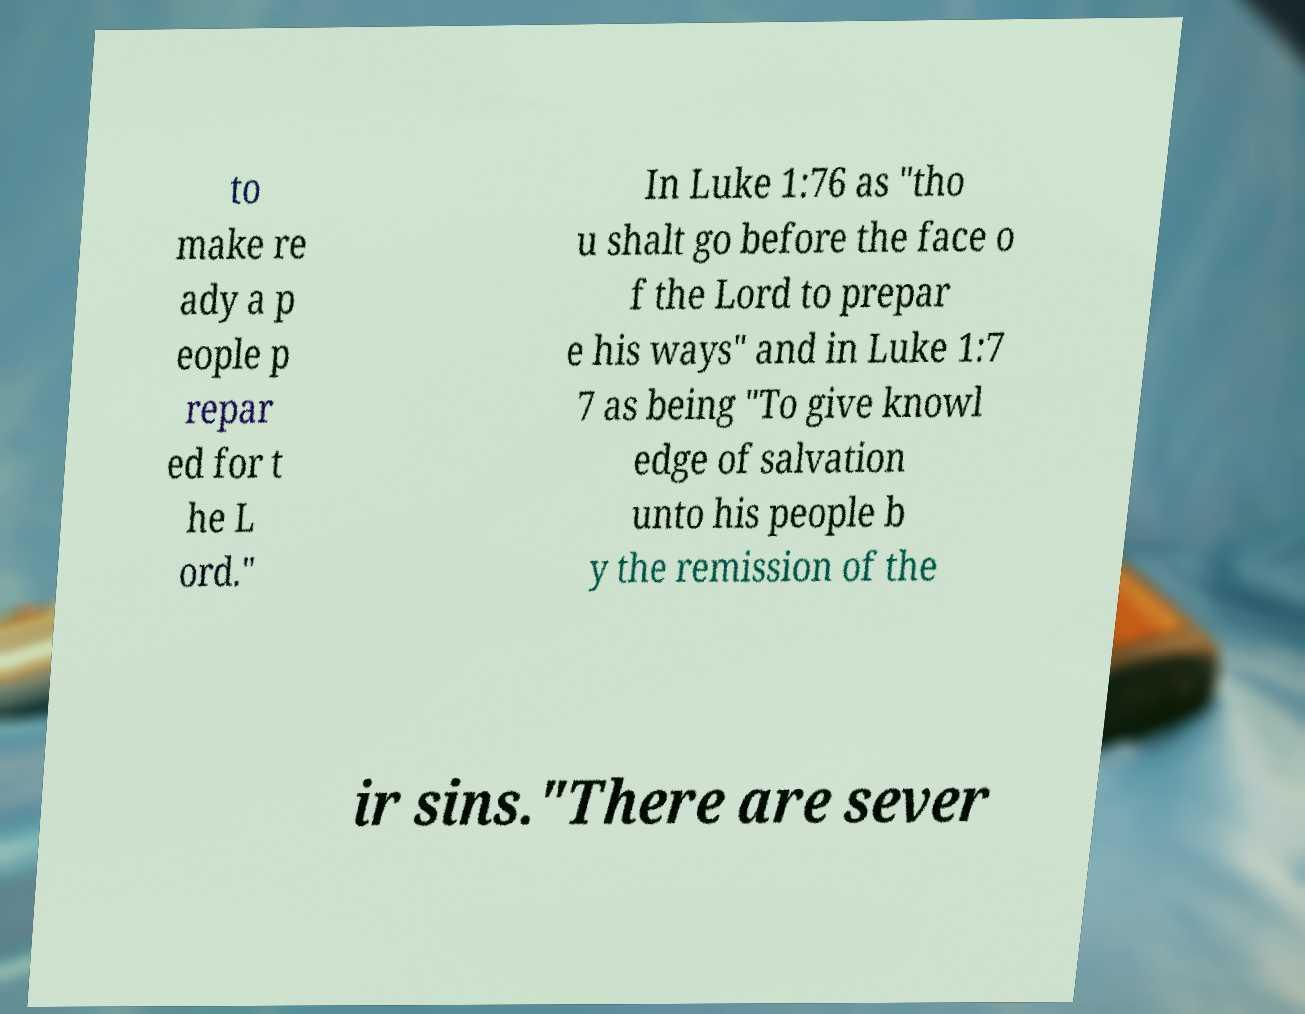Can you read and provide the text displayed in the image?This photo seems to have some interesting text. Can you extract and type it out for me? to make re ady a p eople p repar ed for t he L ord." In Luke 1:76 as "tho u shalt go before the face o f the Lord to prepar e his ways" and in Luke 1:7 7 as being "To give knowl edge of salvation unto his people b y the remission of the ir sins."There are sever 